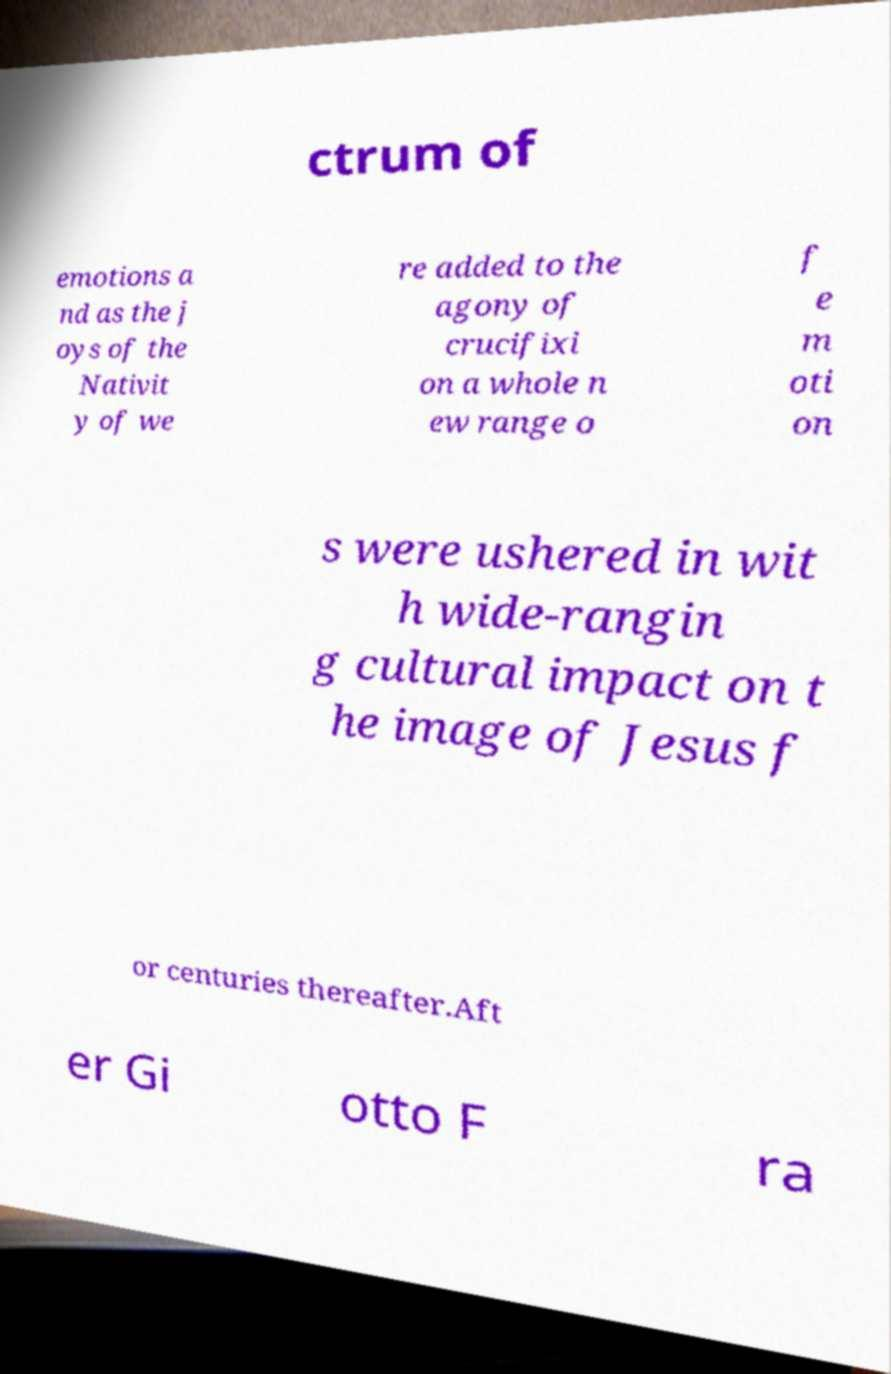Could you assist in decoding the text presented in this image and type it out clearly? ctrum of emotions a nd as the j oys of the Nativit y of we re added to the agony of crucifixi on a whole n ew range o f e m oti on s were ushered in wit h wide-rangin g cultural impact on t he image of Jesus f or centuries thereafter.Aft er Gi otto F ra 